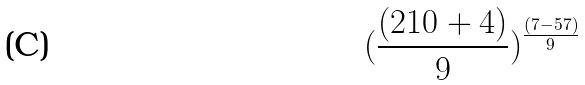Convert formula to latex. <formula><loc_0><loc_0><loc_500><loc_500>( \frac { ( 2 1 0 + 4 ) } { 9 } ) ^ { \frac { ( 7 - 5 7 ) } { 9 } }</formula> 